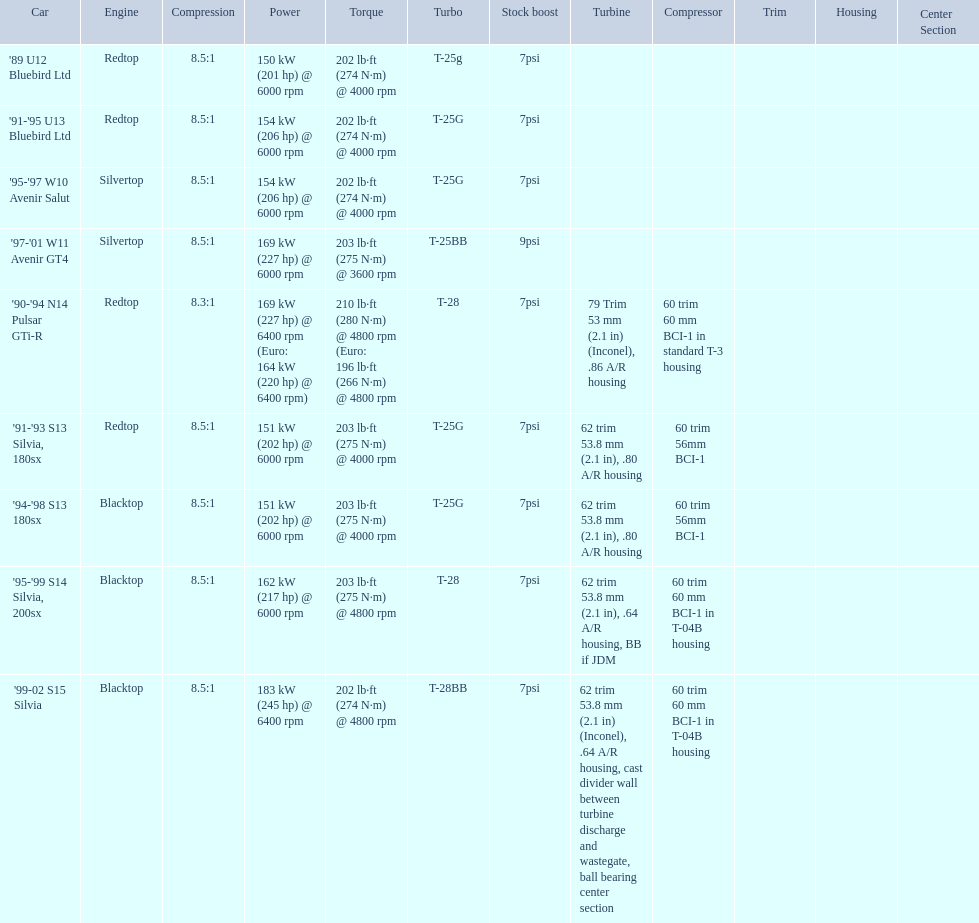What are all of the cars? '89 U12 Bluebird Ltd, '91-'95 U13 Bluebird Ltd, '95-'97 W10 Avenir Salut, '97-'01 W11 Avenir GT4, '90-'94 N14 Pulsar GTi-R, '91-'93 S13 Silvia, 180sx, '94-'98 S13 180sx, '95-'99 S14 Silvia, 200sx, '99-02 S15 Silvia. What is their rated power? 150 kW (201 hp) @ 6000 rpm, 154 kW (206 hp) @ 6000 rpm, 154 kW (206 hp) @ 6000 rpm, 169 kW (227 hp) @ 6000 rpm, 169 kW (227 hp) @ 6400 rpm (Euro: 164 kW (220 hp) @ 6400 rpm), 151 kW (202 hp) @ 6000 rpm, 151 kW (202 hp) @ 6000 rpm, 162 kW (217 hp) @ 6000 rpm, 183 kW (245 hp) @ 6400 rpm. Which car has the most power? '99-02 S15 Silvia. 